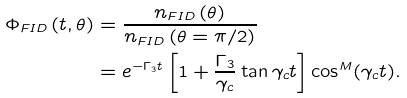<formula> <loc_0><loc_0><loc_500><loc_500>\Phi _ { F I D } \left ( t , \theta \right ) & = \frac { n _ { F I D } \left ( \theta \right ) } { n _ { F I D } \left ( \theta = \pi / 2 \right ) } \\ & = e ^ { - \Gamma _ { 3 } t } \left [ 1 + \frac { \Gamma _ { 3 } } { \gamma _ { c } } \tan \gamma _ { c } t \right ] \cos ^ { M } ( \gamma _ { c } t ) .</formula> 